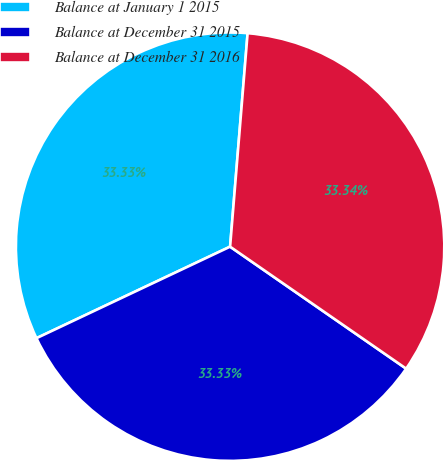Convert chart to OTSL. <chart><loc_0><loc_0><loc_500><loc_500><pie_chart><fcel>Balance at January 1 2015<fcel>Balance at December 31 2015<fcel>Balance at December 31 2016<nl><fcel>33.33%<fcel>33.33%<fcel>33.34%<nl></chart> 